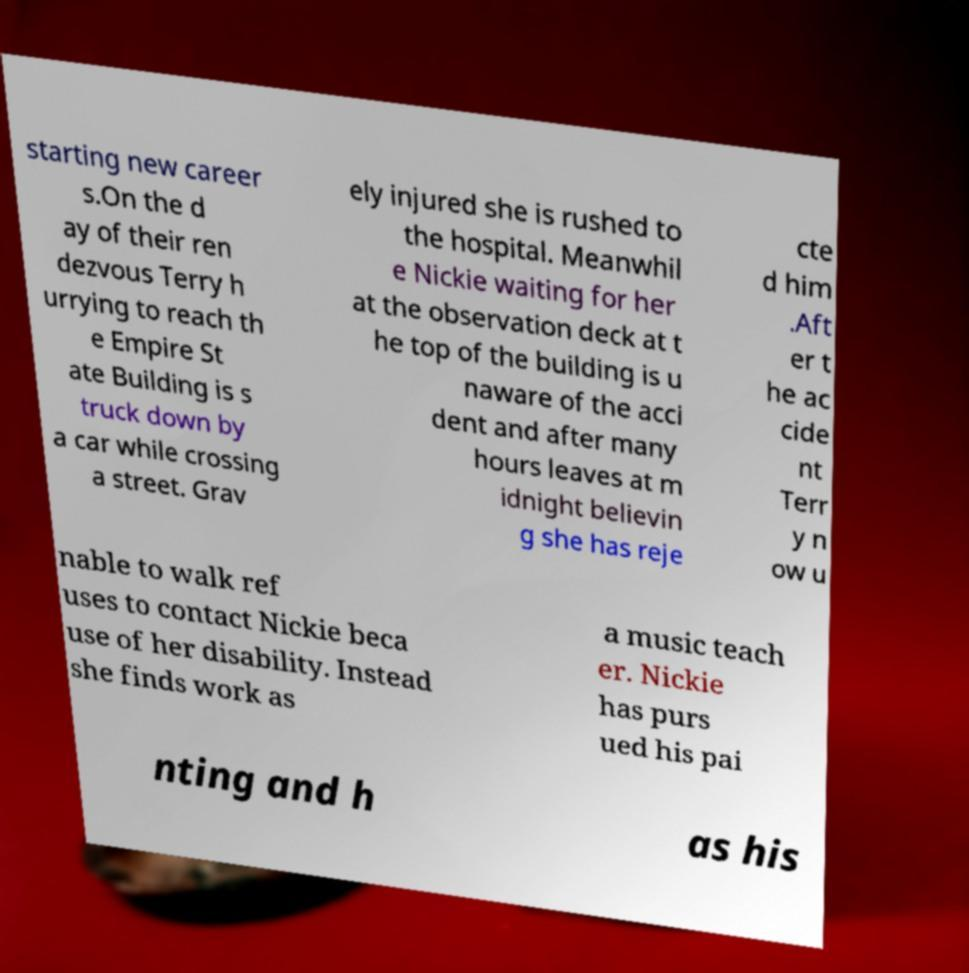I need the written content from this picture converted into text. Can you do that? starting new career s.On the d ay of their ren dezvous Terry h urrying to reach th e Empire St ate Building is s truck down by a car while crossing a street. Grav ely injured she is rushed to the hospital. Meanwhil e Nickie waiting for her at the observation deck at t he top of the building is u naware of the acci dent and after many hours leaves at m idnight believin g she has reje cte d him .Aft er t he ac cide nt Terr y n ow u nable to walk ref uses to contact Nickie beca use of her disability. Instead she finds work as a music teach er. Nickie has purs ued his pai nting and h as his 